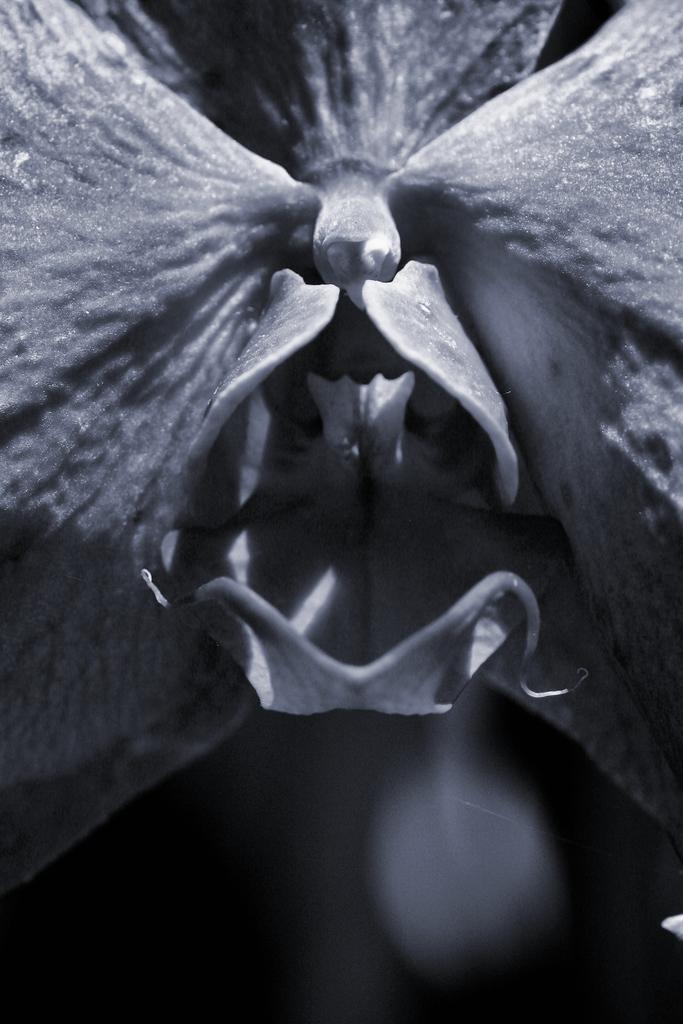What is the color scheme of the image? The image is black and white. What type of object can be seen in the image? There is a flower in the image. What type of pickle is being used as a prop in the image? There is no pickle present in the image; it only features a flower in a black and white color scheme. 